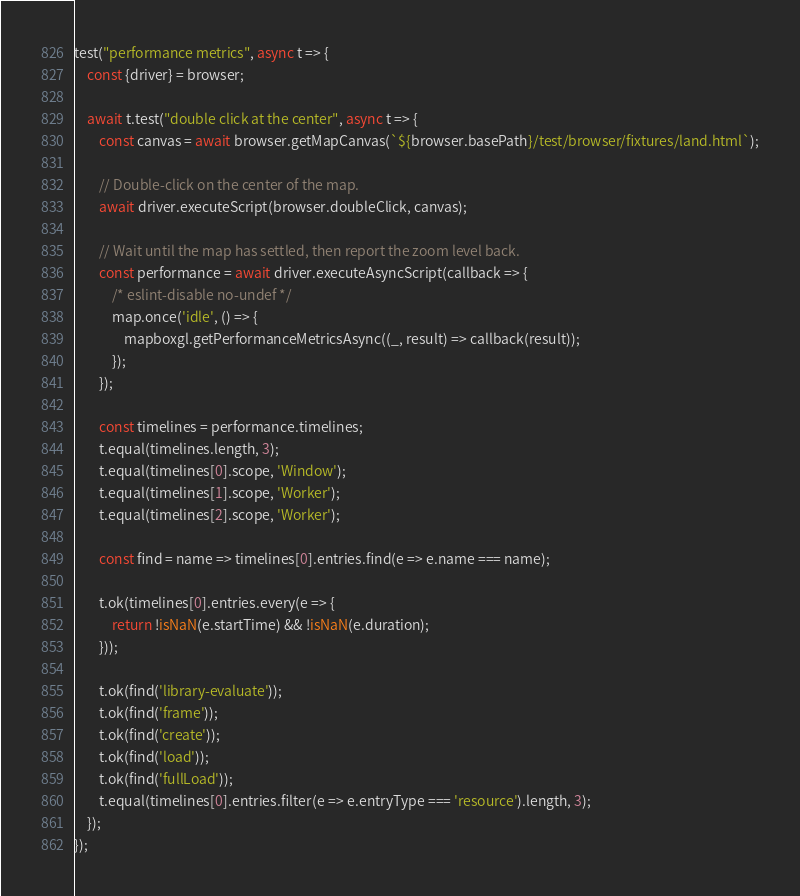Convert code to text. <code><loc_0><loc_0><loc_500><loc_500><_JavaScript_>
test("performance metrics", async t => {
    const {driver} = browser;

    await t.test("double click at the center", async t => {
        const canvas = await browser.getMapCanvas(`${browser.basePath}/test/browser/fixtures/land.html`);

        // Double-click on the center of the map.
        await driver.executeScript(browser.doubleClick, canvas);

        // Wait until the map has settled, then report the zoom level back.
        const performance = await driver.executeAsyncScript(callback => {
            /* eslint-disable no-undef */
            map.once('idle', () => {
                mapboxgl.getPerformanceMetricsAsync((_, result) => callback(result));
            });
        });

        const timelines = performance.timelines;
        t.equal(timelines.length, 3);
        t.equal(timelines[0].scope, 'Window');
        t.equal(timelines[1].scope, 'Worker');
        t.equal(timelines[2].scope, 'Worker');

        const find = name => timelines[0].entries.find(e => e.name === name);

        t.ok(timelines[0].entries.every(e => {
            return !isNaN(e.startTime) && !isNaN(e.duration);
        }));

        t.ok(find('library-evaluate'));
        t.ok(find('frame'));
        t.ok(find('create'));
        t.ok(find('load'));
        t.ok(find('fullLoad'));
        t.equal(timelines[0].entries.filter(e => e.entryType === 'resource').length, 3);
    });
});
</code> 